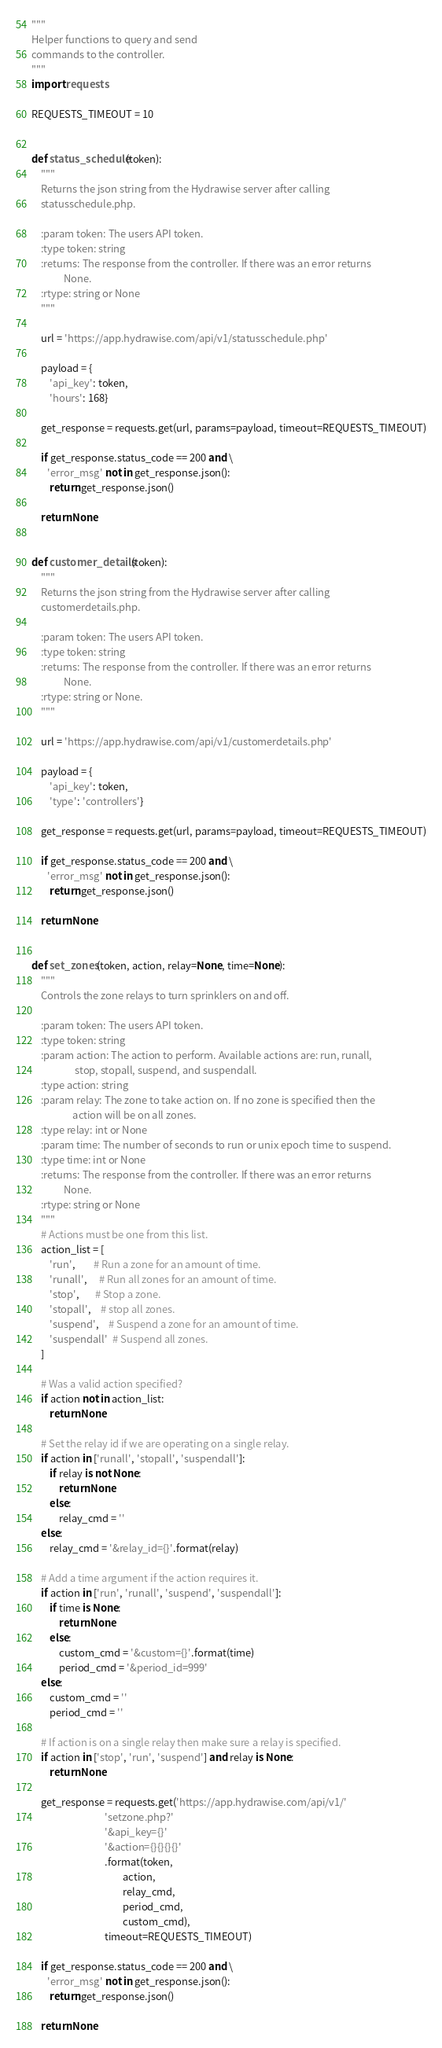<code> <loc_0><loc_0><loc_500><loc_500><_Python_>"""
Helper functions to query and send
commands to the controller.
"""
import requests

REQUESTS_TIMEOUT = 10


def status_schedule(token):
    """
    Returns the json string from the Hydrawise server after calling
    statusschedule.php.

    :param token: The users API token.
    :type token: string
    :returns: The response from the controller. If there was an error returns
              None.
    :rtype: string or None
    """

    url = 'https://app.hydrawise.com/api/v1/statusschedule.php'

    payload = {
        'api_key': token,
        'hours': 168}

    get_response = requests.get(url, params=payload, timeout=REQUESTS_TIMEOUT)

    if get_response.status_code == 200 and \
       'error_msg' not in get_response.json():
        return get_response.json()

    return None


def customer_details(token):
    """
    Returns the json string from the Hydrawise server after calling
    customerdetails.php.

    :param token: The users API token.
    :type token: string
    :returns: The response from the controller. If there was an error returns
              None.
    :rtype: string or None.
    """

    url = 'https://app.hydrawise.com/api/v1/customerdetails.php'

    payload = {
        'api_key': token,
        'type': 'controllers'}

    get_response = requests.get(url, params=payload, timeout=REQUESTS_TIMEOUT)

    if get_response.status_code == 200 and \
       'error_msg' not in get_response.json():
        return get_response.json()

    return None


def set_zones(token, action, relay=None, time=None):
    """
    Controls the zone relays to turn sprinklers on and off.

    :param token: The users API token.
    :type token: string
    :param action: The action to perform. Available actions are: run, runall,
                   stop, stopall, suspend, and suspendall.
    :type action: string
    :param relay: The zone to take action on. If no zone is specified then the
                  action will be on all zones.
    :type relay: int or None
    :param time: The number of seconds to run or unix epoch time to suspend.
    :type time: int or None
    :returns: The response from the controller. If there was an error returns
              None.
    :rtype: string or None
    """
    # Actions must be one from this list.
    action_list = [
        'run',        # Run a zone for an amount of time.
        'runall',     # Run all zones for an amount of time.
        'stop',       # Stop a zone.
        'stopall',    # stop all zones.
        'suspend',    # Suspend a zone for an amount of time.
        'suspendall'  # Suspend all zones.
    ]

    # Was a valid action specified?
    if action not in action_list:
        return None

    # Set the relay id if we are operating on a single relay.
    if action in ['runall', 'stopall', 'suspendall']:
        if relay is not None:
            return None
        else:
            relay_cmd = ''
    else:
        relay_cmd = '&relay_id={}'.format(relay)

    # Add a time argument if the action requires it.
    if action in ['run', 'runall', 'suspend', 'suspendall']:
        if time is None:
            return None
        else:
            custom_cmd = '&custom={}'.format(time)
            period_cmd = '&period_id=999'
    else:
        custom_cmd = ''
        period_cmd = ''

    # If action is on a single relay then make sure a relay is specified.
    if action in ['stop', 'run', 'suspend'] and relay is None:
        return None

    get_response = requests.get('https://app.hydrawise.com/api/v1/'
                                'setzone.php?'
                                '&api_key={}'
                                '&action={}{}{}{}'
                                .format(token,
                                        action,
                                        relay_cmd,
                                        period_cmd,
                                        custom_cmd),
                                timeout=REQUESTS_TIMEOUT)

    if get_response.status_code == 200 and \
       'error_msg' not in get_response.json():
        return get_response.json()

    return None
</code> 